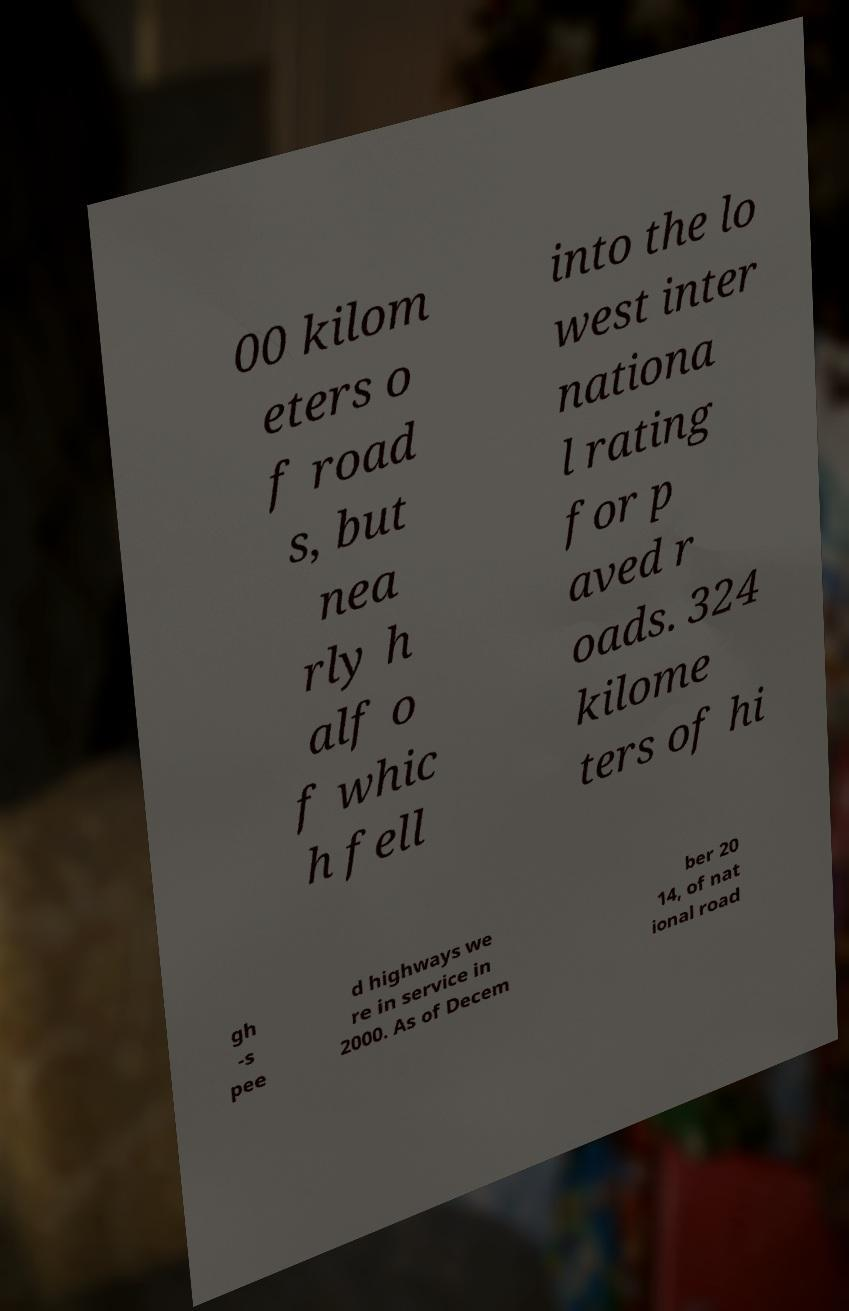Please read and relay the text visible in this image. What does it say? 00 kilom eters o f road s, but nea rly h alf o f whic h fell into the lo west inter nationa l rating for p aved r oads. 324 kilome ters of hi gh -s pee d highways we re in service in 2000. As of Decem ber 20 14, of nat ional road 